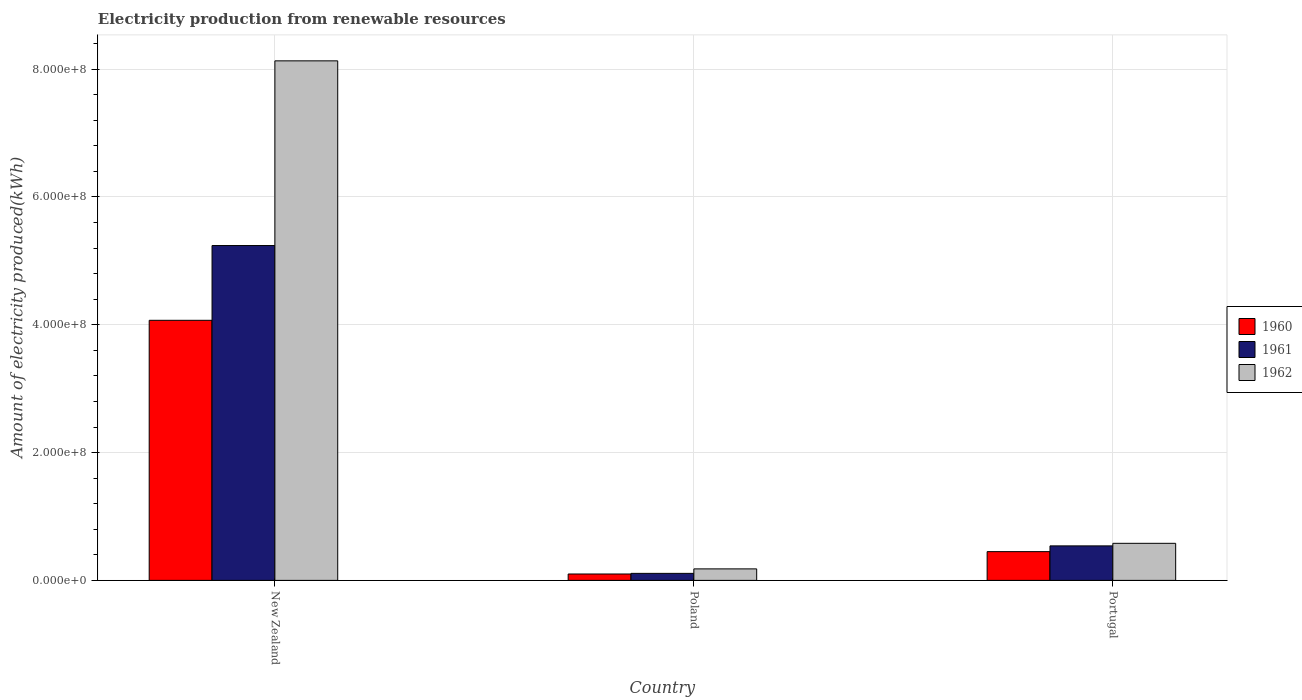How many groups of bars are there?
Make the answer very short. 3. How many bars are there on the 2nd tick from the right?
Offer a very short reply. 3. What is the label of the 3rd group of bars from the left?
Make the answer very short. Portugal. In how many cases, is the number of bars for a given country not equal to the number of legend labels?
Ensure brevity in your answer.  0. What is the amount of electricity produced in 1962 in Portugal?
Keep it short and to the point. 5.80e+07. Across all countries, what is the maximum amount of electricity produced in 1961?
Give a very brief answer. 5.24e+08. Across all countries, what is the minimum amount of electricity produced in 1961?
Provide a short and direct response. 1.10e+07. In which country was the amount of electricity produced in 1962 maximum?
Provide a short and direct response. New Zealand. In which country was the amount of electricity produced in 1960 minimum?
Offer a very short reply. Poland. What is the total amount of electricity produced in 1960 in the graph?
Give a very brief answer. 4.62e+08. What is the difference between the amount of electricity produced in 1961 in New Zealand and that in Portugal?
Provide a succinct answer. 4.70e+08. What is the difference between the amount of electricity produced in 1962 in Portugal and the amount of electricity produced in 1961 in Poland?
Your answer should be very brief. 4.70e+07. What is the average amount of electricity produced in 1961 per country?
Your answer should be compact. 1.96e+08. What is the difference between the amount of electricity produced of/in 1962 and amount of electricity produced of/in 1961 in Poland?
Provide a short and direct response. 7.00e+06. What is the ratio of the amount of electricity produced in 1962 in Poland to that in Portugal?
Ensure brevity in your answer.  0.31. Is the amount of electricity produced in 1961 in New Zealand less than that in Portugal?
Your answer should be very brief. No. Is the difference between the amount of electricity produced in 1962 in Poland and Portugal greater than the difference between the amount of electricity produced in 1961 in Poland and Portugal?
Offer a terse response. Yes. What is the difference between the highest and the second highest amount of electricity produced in 1960?
Your answer should be very brief. 3.62e+08. What is the difference between the highest and the lowest amount of electricity produced in 1961?
Ensure brevity in your answer.  5.13e+08. In how many countries, is the amount of electricity produced in 1961 greater than the average amount of electricity produced in 1961 taken over all countries?
Offer a very short reply. 1. Is the sum of the amount of electricity produced in 1962 in Poland and Portugal greater than the maximum amount of electricity produced in 1960 across all countries?
Your answer should be very brief. No. Is it the case that in every country, the sum of the amount of electricity produced in 1961 and amount of electricity produced in 1960 is greater than the amount of electricity produced in 1962?
Your answer should be very brief. Yes. How many countries are there in the graph?
Offer a terse response. 3. Does the graph contain any zero values?
Your answer should be compact. No. Does the graph contain grids?
Your response must be concise. Yes. How many legend labels are there?
Offer a very short reply. 3. How are the legend labels stacked?
Make the answer very short. Vertical. What is the title of the graph?
Make the answer very short. Electricity production from renewable resources. Does "2000" appear as one of the legend labels in the graph?
Make the answer very short. No. What is the label or title of the Y-axis?
Make the answer very short. Amount of electricity produced(kWh). What is the Amount of electricity produced(kWh) in 1960 in New Zealand?
Keep it short and to the point. 4.07e+08. What is the Amount of electricity produced(kWh) in 1961 in New Zealand?
Provide a succinct answer. 5.24e+08. What is the Amount of electricity produced(kWh) of 1962 in New Zealand?
Give a very brief answer. 8.13e+08. What is the Amount of electricity produced(kWh) of 1960 in Poland?
Offer a very short reply. 1.00e+07. What is the Amount of electricity produced(kWh) in 1961 in Poland?
Your response must be concise. 1.10e+07. What is the Amount of electricity produced(kWh) in 1962 in Poland?
Your answer should be very brief. 1.80e+07. What is the Amount of electricity produced(kWh) of 1960 in Portugal?
Make the answer very short. 4.50e+07. What is the Amount of electricity produced(kWh) in 1961 in Portugal?
Provide a short and direct response. 5.40e+07. What is the Amount of electricity produced(kWh) in 1962 in Portugal?
Your response must be concise. 5.80e+07. Across all countries, what is the maximum Amount of electricity produced(kWh) of 1960?
Provide a short and direct response. 4.07e+08. Across all countries, what is the maximum Amount of electricity produced(kWh) in 1961?
Your answer should be compact. 5.24e+08. Across all countries, what is the maximum Amount of electricity produced(kWh) in 1962?
Your answer should be compact. 8.13e+08. Across all countries, what is the minimum Amount of electricity produced(kWh) in 1960?
Your response must be concise. 1.00e+07. Across all countries, what is the minimum Amount of electricity produced(kWh) of 1961?
Keep it short and to the point. 1.10e+07. Across all countries, what is the minimum Amount of electricity produced(kWh) of 1962?
Your response must be concise. 1.80e+07. What is the total Amount of electricity produced(kWh) of 1960 in the graph?
Keep it short and to the point. 4.62e+08. What is the total Amount of electricity produced(kWh) in 1961 in the graph?
Your answer should be compact. 5.89e+08. What is the total Amount of electricity produced(kWh) in 1962 in the graph?
Offer a very short reply. 8.89e+08. What is the difference between the Amount of electricity produced(kWh) of 1960 in New Zealand and that in Poland?
Your answer should be compact. 3.97e+08. What is the difference between the Amount of electricity produced(kWh) of 1961 in New Zealand and that in Poland?
Offer a very short reply. 5.13e+08. What is the difference between the Amount of electricity produced(kWh) of 1962 in New Zealand and that in Poland?
Offer a terse response. 7.95e+08. What is the difference between the Amount of electricity produced(kWh) in 1960 in New Zealand and that in Portugal?
Give a very brief answer. 3.62e+08. What is the difference between the Amount of electricity produced(kWh) of 1961 in New Zealand and that in Portugal?
Your answer should be very brief. 4.70e+08. What is the difference between the Amount of electricity produced(kWh) in 1962 in New Zealand and that in Portugal?
Provide a succinct answer. 7.55e+08. What is the difference between the Amount of electricity produced(kWh) of 1960 in Poland and that in Portugal?
Ensure brevity in your answer.  -3.50e+07. What is the difference between the Amount of electricity produced(kWh) in 1961 in Poland and that in Portugal?
Provide a succinct answer. -4.30e+07. What is the difference between the Amount of electricity produced(kWh) of 1962 in Poland and that in Portugal?
Offer a very short reply. -4.00e+07. What is the difference between the Amount of electricity produced(kWh) of 1960 in New Zealand and the Amount of electricity produced(kWh) of 1961 in Poland?
Ensure brevity in your answer.  3.96e+08. What is the difference between the Amount of electricity produced(kWh) of 1960 in New Zealand and the Amount of electricity produced(kWh) of 1962 in Poland?
Provide a short and direct response. 3.89e+08. What is the difference between the Amount of electricity produced(kWh) of 1961 in New Zealand and the Amount of electricity produced(kWh) of 1962 in Poland?
Offer a very short reply. 5.06e+08. What is the difference between the Amount of electricity produced(kWh) of 1960 in New Zealand and the Amount of electricity produced(kWh) of 1961 in Portugal?
Provide a short and direct response. 3.53e+08. What is the difference between the Amount of electricity produced(kWh) in 1960 in New Zealand and the Amount of electricity produced(kWh) in 1962 in Portugal?
Your answer should be compact. 3.49e+08. What is the difference between the Amount of electricity produced(kWh) of 1961 in New Zealand and the Amount of electricity produced(kWh) of 1962 in Portugal?
Offer a terse response. 4.66e+08. What is the difference between the Amount of electricity produced(kWh) in 1960 in Poland and the Amount of electricity produced(kWh) in 1961 in Portugal?
Give a very brief answer. -4.40e+07. What is the difference between the Amount of electricity produced(kWh) of 1960 in Poland and the Amount of electricity produced(kWh) of 1962 in Portugal?
Provide a short and direct response. -4.80e+07. What is the difference between the Amount of electricity produced(kWh) in 1961 in Poland and the Amount of electricity produced(kWh) in 1962 in Portugal?
Make the answer very short. -4.70e+07. What is the average Amount of electricity produced(kWh) of 1960 per country?
Give a very brief answer. 1.54e+08. What is the average Amount of electricity produced(kWh) of 1961 per country?
Provide a short and direct response. 1.96e+08. What is the average Amount of electricity produced(kWh) in 1962 per country?
Make the answer very short. 2.96e+08. What is the difference between the Amount of electricity produced(kWh) in 1960 and Amount of electricity produced(kWh) in 1961 in New Zealand?
Make the answer very short. -1.17e+08. What is the difference between the Amount of electricity produced(kWh) of 1960 and Amount of electricity produced(kWh) of 1962 in New Zealand?
Ensure brevity in your answer.  -4.06e+08. What is the difference between the Amount of electricity produced(kWh) of 1961 and Amount of electricity produced(kWh) of 1962 in New Zealand?
Your answer should be very brief. -2.89e+08. What is the difference between the Amount of electricity produced(kWh) in 1960 and Amount of electricity produced(kWh) in 1961 in Poland?
Your response must be concise. -1.00e+06. What is the difference between the Amount of electricity produced(kWh) in 1960 and Amount of electricity produced(kWh) in 1962 in Poland?
Provide a short and direct response. -8.00e+06. What is the difference between the Amount of electricity produced(kWh) in 1961 and Amount of electricity produced(kWh) in 1962 in Poland?
Provide a succinct answer. -7.00e+06. What is the difference between the Amount of electricity produced(kWh) of 1960 and Amount of electricity produced(kWh) of 1961 in Portugal?
Your answer should be compact. -9.00e+06. What is the difference between the Amount of electricity produced(kWh) in 1960 and Amount of electricity produced(kWh) in 1962 in Portugal?
Give a very brief answer. -1.30e+07. What is the ratio of the Amount of electricity produced(kWh) of 1960 in New Zealand to that in Poland?
Your answer should be compact. 40.7. What is the ratio of the Amount of electricity produced(kWh) of 1961 in New Zealand to that in Poland?
Provide a short and direct response. 47.64. What is the ratio of the Amount of electricity produced(kWh) in 1962 in New Zealand to that in Poland?
Provide a short and direct response. 45.17. What is the ratio of the Amount of electricity produced(kWh) of 1960 in New Zealand to that in Portugal?
Provide a succinct answer. 9.04. What is the ratio of the Amount of electricity produced(kWh) of 1961 in New Zealand to that in Portugal?
Give a very brief answer. 9.7. What is the ratio of the Amount of electricity produced(kWh) in 1962 in New Zealand to that in Portugal?
Offer a terse response. 14.02. What is the ratio of the Amount of electricity produced(kWh) of 1960 in Poland to that in Portugal?
Ensure brevity in your answer.  0.22. What is the ratio of the Amount of electricity produced(kWh) in 1961 in Poland to that in Portugal?
Provide a short and direct response. 0.2. What is the ratio of the Amount of electricity produced(kWh) in 1962 in Poland to that in Portugal?
Give a very brief answer. 0.31. What is the difference between the highest and the second highest Amount of electricity produced(kWh) of 1960?
Ensure brevity in your answer.  3.62e+08. What is the difference between the highest and the second highest Amount of electricity produced(kWh) in 1961?
Ensure brevity in your answer.  4.70e+08. What is the difference between the highest and the second highest Amount of electricity produced(kWh) in 1962?
Your response must be concise. 7.55e+08. What is the difference between the highest and the lowest Amount of electricity produced(kWh) in 1960?
Your response must be concise. 3.97e+08. What is the difference between the highest and the lowest Amount of electricity produced(kWh) in 1961?
Make the answer very short. 5.13e+08. What is the difference between the highest and the lowest Amount of electricity produced(kWh) of 1962?
Offer a very short reply. 7.95e+08. 